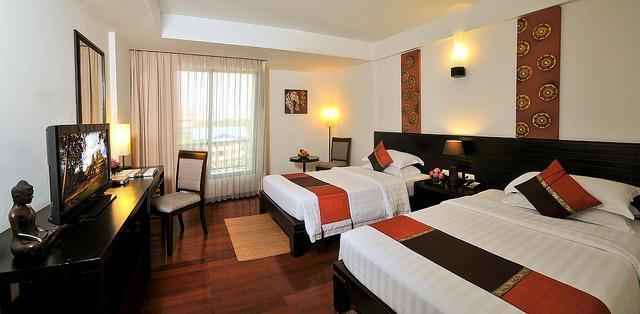How many beds?
Give a very brief answer. 2. How many beds can you see?
Give a very brief answer. 2. 